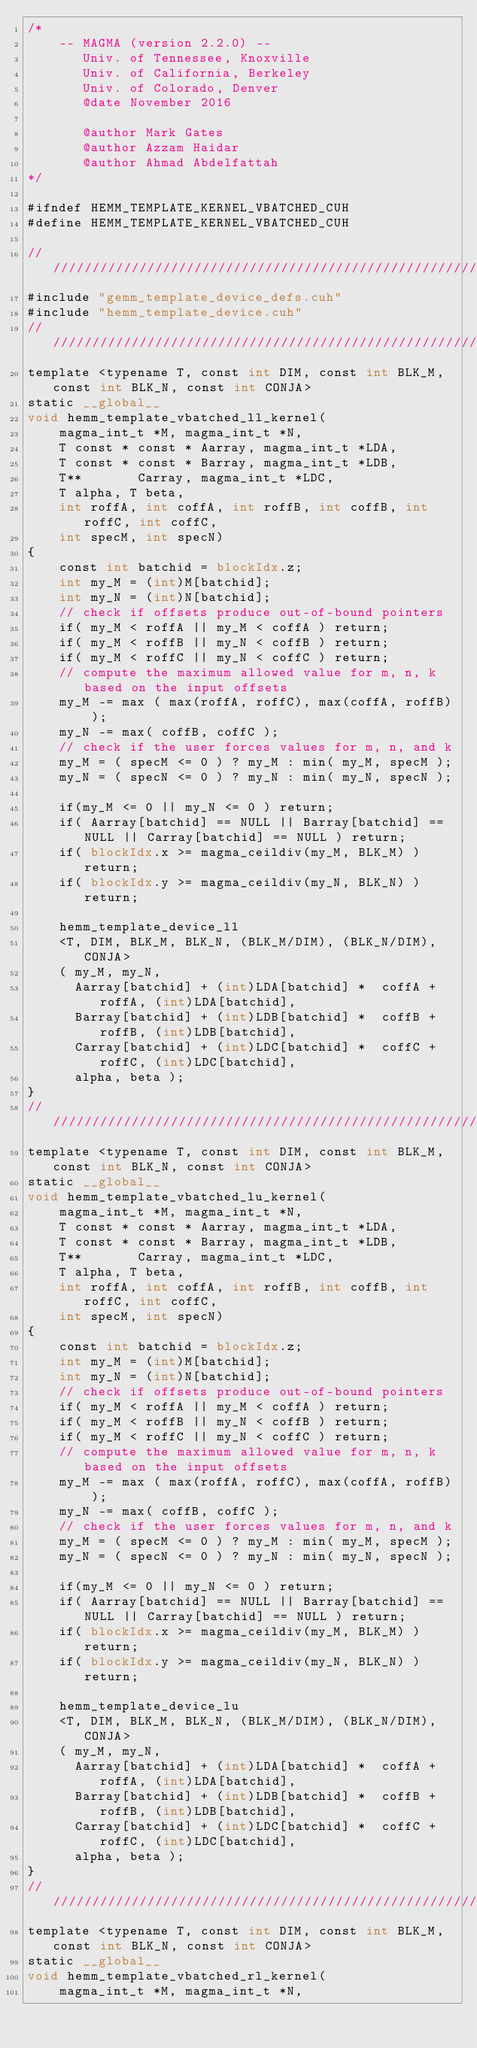Convert code to text. <code><loc_0><loc_0><loc_500><loc_500><_Cuda_>/*
    -- MAGMA (version 2.2.0) --
       Univ. of Tennessee, Knoxville
       Univ. of California, Berkeley
       Univ. of Colorado, Denver
       @date November 2016
       
       @author Mark Gates
       @author Azzam Haidar
       @author Ahmad Abdelfattah
*/

#ifndef HEMM_TEMPLATE_KERNEL_VBATCHED_CUH
#define HEMM_TEMPLATE_KERNEL_VBATCHED_CUH

////////////////////////////////////////////////////////////////////////////////////////////////////
#include "gemm_template_device_defs.cuh"
#include "hemm_template_device.cuh"
////////////////////////////////////////////////////////////////////////////////////////////////////
template <typename T, const int DIM, const int BLK_M, const int BLK_N, const int CONJA>
static __global__
void hemm_template_vbatched_ll_kernel(
    magma_int_t *M, magma_int_t *N, 
    T const * const * Aarray, magma_int_t *LDA,
    T const * const * Barray, magma_int_t *LDB,
    T**       Carray, magma_int_t *LDC,
    T alpha, T beta, 
    int roffA, int coffA, int roffB, int coffB, int roffC, int coffC, 
    int specM, int specN)
{
    const int batchid = blockIdx.z;
    int my_M = (int)M[batchid];
    int my_N = (int)N[batchid];
    // check if offsets produce out-of-bound pointers
    if( my_M < roffA || my_M < coffA ) return;
    if( my_M < roffB || my_N < coffB ) return;
    if( my_M < roffC || my_N < coffC ) return;
    // compute the maximum allowed value for m, n, k based on the input offsets
    my_M -= max ( max(roffA, roffC), max(coffA, roffB) );
    my_N -= max( coffB, coffC );
    // check if the user forces values for m, n, and k
    my_M = ( specM <= 0 ) ? my_M : min( my_M, specM );
    my_N = ( specN <= 0 ) ? my_N : min( my_N, specN );
    
    if(my_M <= 0 || my_N <= 0 ) return;
    if( Aarray[batchid] == NULL || Barray[batchid] == NULL || Carray[batchid] == NULL ) return;
    if( blockIdx.x >= magma_ceildiv(my_M, BLK_M) ) return;
    if( blockIdx.y >= magma_ceildiv(my_N, BLK_N) ) return;
    
    hemm_template_device_ll
    <T, DIM, BLK_M, BLK_N, (BLK_M/DIM), (BLK_N/DIM), CONJA>
    ( my_M, my_N, 
      Aarray[batchid] + (int)LDA[batchid] *  coffA + roffA, (int)LDA[batchid], 
      Barray[batchid] + (int)LDB[batchid] *  coffB + roffB, (int)LDB[batchid], 
      Carray[batchid] + (int)LDC[batchid] *  coffC + roffC, (int)LDC[batchid], 
      alpha, beta );
}
////////////////////////////////////////////////////////////////////////////////////////////////////
template <typename T, const int DIM, const int BLK_M, const int BLK_N, const int CONJA>
static __global__
void hemm_template_vbatched_lu_kernel(
    magma_int_t *M, magma_int_t *N, 
    T const * const * Aarray, magma_int_t *LDA,
    T const * const * Barray, magma_int_t *LDB,
    T**       Carray, magma_int_t *LDC,
    T alpha, T beta, 
    int roffA, int coffA, int roffB, int coffB, int roffC, int coffC, 
    int specM, int specN)
{
    const int batchid = blockIdx.z;
    int my_M = (int)M[batchid];
    int my_N = (int)N[batchid];
    // check if offsets produce out-of-bound pointers
    if( my_M < roffA || my_M < coffA ) return;
    if( my_M < roffB || my_N < coffB ) return;
    if( my_M < roffC || my_N < coffC ) return;
    // compute the maximum allowed value for m, n, k based on the input offsets
    my_M -= max ( max(roffA, roffC), max(coffA, roffB) );
    my_N -= max( coffB, coffC );
    // check if the user forces values for m, n, and k
    my_M = ( specM <= 0 ) ? my_M : min( my_M, specM );
    my_N = ( specN <= 0 ) ? my_N : min( my_N, specN );
    
    if(my_M <= 0 || my_N <= 0 ) return;
    if( Aarray[batchid] == NULL || Barray[batchid] == NULL || Carray[batchid] == NULL ) return;
    if( blockIdx.x >= magma_ceildiv(my_M, BLK_M) ) return;
    if( blockIdx.y >= magma_ceildiv(my_N, BLK_N) ) return;
    
    hemm_template_device_lu
    <T, DIM, BLK_M, BLK_N, (BLK_M/DIM), (BLK_N/DIM), CONJA>
    ( my_M, my_N, 
      Aarray[batchid] + (int)LDA[batchid] *  coffA + roffA, (int)LDA[batchid], 
      Barray[batchid] + (int)LDB[batchid] *  coffB + roffB, (int)LDB[batchid], 
      Carray[batchid] + (int)LDC[batchid] *  coffC + roffC, (int)LDC[batchid], 
      alpha, beta );
}
////////////////////////////////////////////////////////////////////////////////////////////////////
template <typename T, const int DIM, const int BLK_M, const int BLK_N, const int CONJA>
static __global__
void hemm_template_vbatched_rl_kernel(
    magma_int_t *M, magma_int_t *N, </code> 